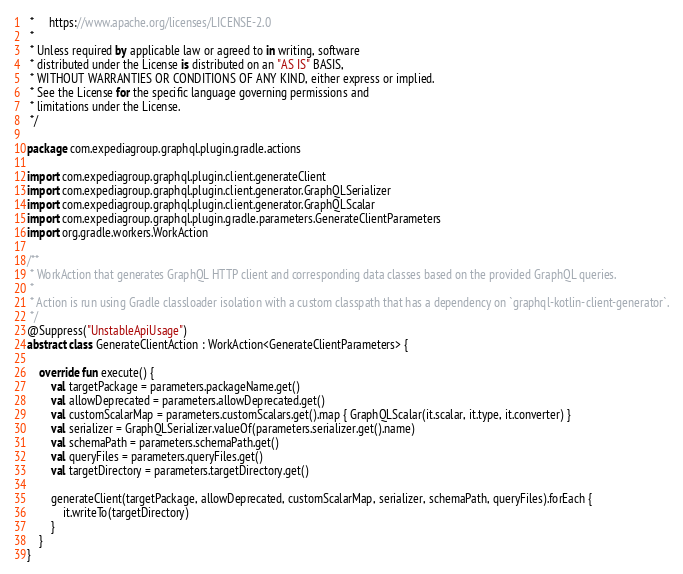<code> <loc_0><loc_0><loc_500><loc_500><_Kotlin_> *     https://www.apache.org/licenses/LICENSE-2.0
 *
 * Unless required by applicable law or agreed to in writing, software
 * distributed under the License is distributed on an "AS IS" BASIS,
 * WITHOUT WARRANTIES OR CONDITIONS OF ANY KIND, either express or implied.
 * See the License for the specific language governing permissions and
 * limitations under the License.
 */

package com.expediagroup.graphql.plugin.gradle.actions

import com.expediagroup.graphql.plugin.client.generateClient
import com.expediagroup.graphql.plugin.client.generator.GraphQLSerializer
import com.expediagroup.graphql.plugin.client.generator.GraphQLScalar
import com.expediagroup.graphql.plugin.gradle.parameters.GenerateClientParameters
import org.gradle.workers.WorkAction

/**
 * WorkAction that generates GraphQL HTTP client and corresponding data classes based on the provided GraphQL queries.
 *
 * Action is run using Gradle classloader isolation with a custom classpath that has a dependency on `graphql-kotlin-client-generator`.
 */
@Suppress("UnstableApiUsage")
abstract class GenerateClientAction : WorkAction<GenerateClientParameters> {

    override fun execute() {
        val targetPackage = parameters.packageName.get()
        val allowDeprecated = parameters.allowDeprecated.get()
        val customScalarMap = parameters.customScalars.get().map { GraphQLScalar(it.scalar, it.type, it.converter) }
        val serializer = GraphQLSerializer.valueOf(parameters.serializer.get().name)
        val schemaPath = parameters.schemaPath.get()
        val queryFiles = parameters.queryFiles.get()
        val targetDirectory = parameters.targetDirectory.get()

        generateClient(targetPackage, allowDeprecated, customScalarMap, serializer, schemaPath, queryFiles).forEach {
            it.writeTo(targetDirectory)
        }
    }
}
</code> 